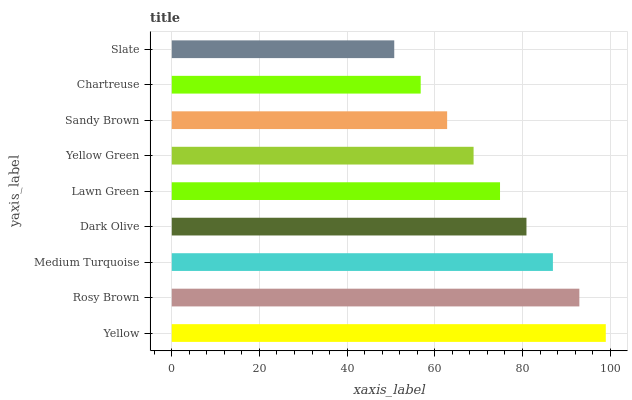Is Slate the minimum?
Answer yes or no. Yes. Is Yellow the maximum?
Answer yes or no. Yes. Is Rosy Brown the minimum?
Answer yes or no. No. Is Rosy Brown the maximum?
Answer yes or no. No. Is Yellow greater than Rosy Brown?
Answer yes or no. Yes. Is Rosy Brown less than Yellow?
Answer yes or no. Yes. Is Rosy Brown greater than Yellow?
Answer yes or no. No. Is Yellow less than Rosy Brown?
Answer yes or no. No. Is Lawn Green the high median?
Answer yes or no. Yes. Is Lawn Green the low median?
Answer yes or no. Yes. Is Yellow the high median?
Answer yes or no. No. Is Yellow Green the low median?
Answer yes or no. No. 